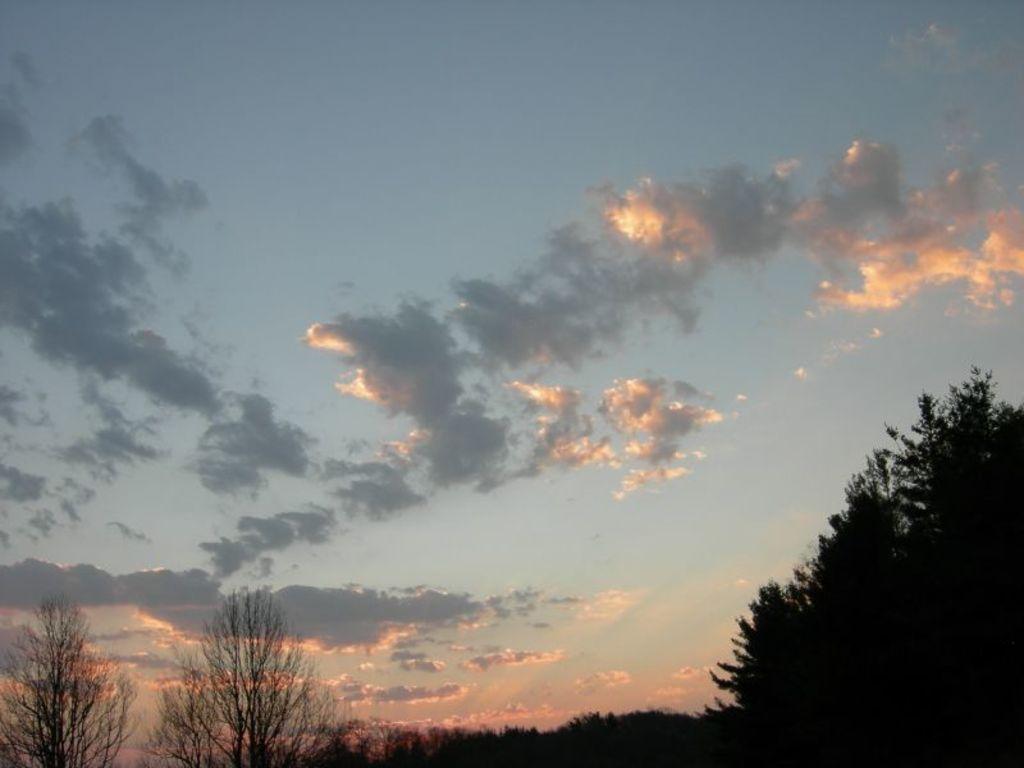Can you describe this image briefly? In this image we can see the blue color sky with some clouds. And trees at the bottom of the image. 